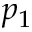<formula> <loc_0><loc_0><loc_500><loc_500>p _ { 1 }</formula> 